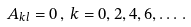<formula> <loc_0><loc_0><loc_500><loc_500>A _ { k l } = 0 \, , \, k = 0 , 2 , 4 , 6 , \dots \, .</formula> 